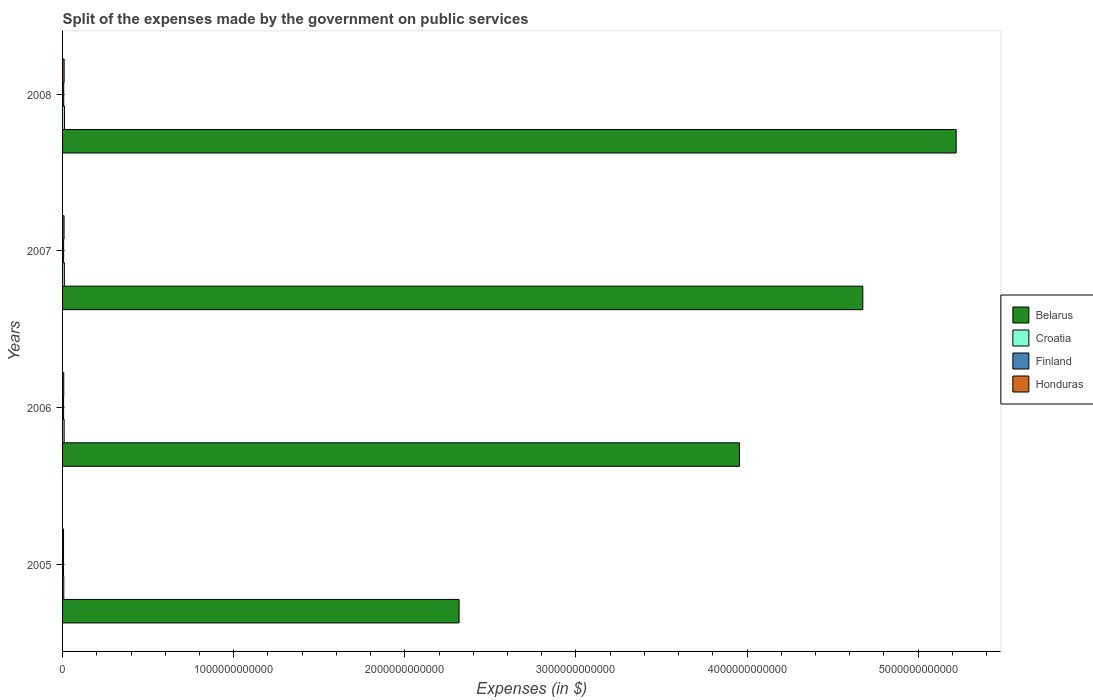How many groups of bars are there?
Keep it short and to the point. 4. How many bars are there on the 2nd tick from the top?
Your answer should be very brief. 4. What is the label of the 2nd group of bars from the top?
Your answer should be very brief. 2007. What is the expenses made by the government on public services in Honduras in 2005?
Ensure brevity in your answer.  5.77e+09. Across all years, what is the maximum expenses made by the government on public services in Croatia?
Give a very brief answer. 1.15e+1. Across all years, what is the minimum expenses made by the government on public services in Honduras?
Keep it short and to the point. 5.77e+09. In which year was the expenses made by the government on public services in Finland maximum?
Offer a very short reply. 2008. What is the total expenses made by the government on public services in Honduras in the graph?
Keep it short and to the point. 3.06e+1. What is the difference between the expenses made by the government on public services in Finland in 2005 and that in 2006?
Offer a terse response. -2.35e+08. What is the difference between the expenses made by the government on public services in Honduras in 2005 and the expenses made by the government on public services in Belarus in 2007?
Provide a succinct answer. -4.67e+12. What is the average expenses made by the government on public services in Croatia per year?
Make the answer very short. 9.57e+09. In the year 2007, what is the difference between the expenses made by the government on public services in Finland and expenses made by the government on public services in Belarus?
Provide a succinct answer. -4.67e+12. In how many years, is the expenses made by the government on public services in Croatia greater than 4600000000000 $?
Give a very brief answer. 0. What is the ratio of the expenses made by the government on public services in Belarus in 2005 to that in 2006?
Provide a succinct answer. 0.59. Is the expenses made by the government on public services in Honduras in 2005 less than that in 2006?
Offer a terse response. Yes. What is the difference between the highest and the second highest expenses made by the government on public services in Honduras?
Make the answer very short. 3.42e+08. What is the difference between the highest and the lowest expenses made by the government on public services in Honduras?
Your answer should be compact. 3.31e+09. In how many years, is the expenses made by the government on public services in Honduras greater than the average expenses made by the government on public services in Honduras taken over all years?
Your answer should be compact. 2. Is the sum of the expenses made by the government on public services in Belarus in 2006 and 2008 greater than the maximum expenses made by the government on public services in Honduras across all years?
Your answer should be very brief. Yes. Is it the case that in every year, the sum of the expenses made by the government on public services in Belarus and expenses made by the government on public services in Croatia is greater than the sum of expenses made by the government on public services in Honduras and expenses made by the government on public services in Finland?
Ensure brevity in your answer.  No. What does the 1st bar from the top in 2007 represents?
Keep it short and to the point. Honduras. What does the 1st bar from the bottom in 2006 represents?
Make the answer very short. Belarus. How many bars are there?
Make the answer very short. 16. What is the difference between two consecutive major ticks on the X-axis?
Give a very brief answer. 1.00e+12. Where does the legend appear in the graph?
Provide a short and direct response. Center right. How are the legend labels stacked?
Offer a terse response. Vertical. What is the title of the graph?
Give a very brief answer. Split of the expenses made by the government on public services. What is the label or title of the X-axis?
Ensure brevity in your answer.  Expenses (in $). What is the label or title of the Y-axis?
Provide a short and direct response. Years. What is the Expenses (in $) of Belarus in 2005?
Provide a short and direct response. 2.32e+12. What is the Expenses (in $) of Croatia in 2005?
Your response must be concise. 7.10e+09. What is the Expenses (in $) of Finland in 2005?
Give a very brief answer. 5.77e+09. What is the Expenses (in $) of Honduras in 2005?
Provide a succinct answer. 5.77e+09. What is the Expenses (in $) in Belarus in 2006?
Your response must be concise. 3.96e+12. What is the Expenses (in $) of Croatia in 2006?
Make the answer very short. 9.19e+09. What is the Expenses (in $) in Finland in 2006?
Make the answer very short. 6.00e+09. What is the Expenses (in $) in Honduras in 2006?
Your response must be concise. 7.04e+09. What is the Expenses (in $) of Belarus in 2007?
Provide a short and direct response. 4.68e+12. What is the Expenses (in $) in Croatia in 2007?
Make the answer very short. 1.05e+1. What is the Expenses (in $) of Finland in 2007?
Your response must be concise. 6.23e+09. What is the Expenses (in $) of Honduras in 2007?
Give a very brief answer. 8.74e+09. What is the Expenses (in $) of Belarus in 2008?
Offer a very short reply. 5.22e+12. What is the Expenses (in $) of Croatia in 2008?
Offer a terse response. 1.15e+1. What is the Expenses (in $) in Finland in 2008?
Keep it short and to the point. 6.73e+09. What is the Expenses (in $) in Honduras in 2008?
Provide a succinct answer. 9.08e+09. Across all years, what is the maximum Expenses (in $) in Belarus?
Keep it short and to the point. 5.22e+12. Across all years, what is the maximum Expenses (in $) in Croatia?
Provide a succinct answer. 1.15e+1. Across all years, what is the maximum Expenses (in $) in Finland?
Give a very brief answer. 6.73e+09. Across all years, what is the maximum Expenses (in $) in Honduras?
Provide a succinct answer. 9.08e+09. Across all years, what is the minimum Expenses (in $) in Belarus?
Provide a succinct answer. 2.32e+12. Across all years, what is the minimum Expenses (in $) in Croatia?
Give a very brief answer. 7.10e+09. Across all years, what is the minimum Expenses (in $) of Finland?
Offer a terse response. 5.77e+09. Across all years, what is the minimum Expenses (in $) in Honduras?
Offer a very short reply. 5.77e+09. What is the total Expenses (in $) of Belarus in the graph?
Provide a short and direct response. 1.62e+13. What is the total Expenses (in $) in Croatia in the graph?
Your answer should be very brief. 3.83e+1. What is the total Expenses (in $) of Finland in the graph?
Keep it short and to the point. 2.47e+1. What is the total Expenses (in $) of Honduras in the graph?
Make the answer very short. 3.06e+1. What is the difference between the Expenses (in $) in Belarus in 2005 and that in 2006?
Your answer should be compact. -1.64e+12. What is the difference between the Expenses (in $) of Croatia in 2005 and that in 2006?
Make the answer very short. -2.09e+09. What is the difference between the Expenses (in $) in Finland in 2005 and that in 2006?
Offer a terse response. -2.35e+08. What is the difference between the Expenses (in $) in Honduras in 2005 and that in 2006?
Your answer should be compact. -1.27e+09. What is the difference between the Expenses (in $) of Belarus in 2005 and that in 2007?
Provide a short and direct response. -2.36e+12. What is the difference between the Expenses (in $) of Croatia in 2005 and that in 2007?
Give a very brief answer. -3.42e+09. What is the difference between the Expenses (in $) of Finland in 2005 and that in 2007?
Ensure brevity in your answer.  -4.57e+08. What is the difference between the Expenses (in $) in Honduras in 2005 and that in 2007?
Offer a very short reply. -2.97e+09. What is the difference between the Expenses (in $) of Belarus in 2005 and that in 2008?
Give a very brief answer. -2.90e+12. What is the difference between the Expenses (in $) of Croatia in 2005 and that in 2008?
Your response must be concise. -4.37e+09. What is the difference between the Expenses (in $) of Finland in 2005 and that in 2008?
Make the answer very short. -9.64e+08. What is the difference between the Expenses (in $) of Honduras in 2005 and that in 2008?
Keep it short and to the point. -3.31e+09. What is the difference between the Expenses (in $) of Belarus in 2006 and that in 2007?
Your response must be concise. -7.21e+11. What is the difference between the Expenses (in $) in Croatia in 2006 and that in 2007?
Your answer should be very brief. -1.32e+09. What is the difference between the Expenses (in $) in Finland in 2006 and that in 2007?
Provide a short and direct response. -2.22e+08. What is the difference between the Expenses (in $) of Honduras in 2006 and that in 2007?
Offer a terse response. -1.70e+09. What is the difference between the Expenses (in $) of Belarus in 2006 and that in 2008?
Ensure brevity in your answer.  -1.27e+12. What is the difference between the Expenses (in $) of Croatia in 2006 and that in 2008?
Make the answer very short. -2.27e+09. What is the difference between the Expenses (in $) in Finland in 2006 and that in 2008?
Provide a succinct answer. -7.29e+08. What is the difference between the Expenses (in $) in Honduras in 2006 and that in 2008?
Give a very brief answer. -2.04e+09. What is the difference between the Expenses (in $) of Belarus in 2007 and that in 2008?
Keep it short and to the point. -5.46e+11. What is the difference between the Expenses (in $) in Croatia in 2007 and that in 2008?
Offer a terse response. -9.51e+08. What is the difference between the Expenses (in $) of Finland in 2007 and that in 2008?
Keep it short and to the point. -5.07e+08. What is the difference between the Expenses (in $) of Honduras in 2007 and that in 2008?
Make the answer very short. -3.42e+08. What is the difference between the Expenses (in $) of Belarus in 2005 and the Expenses (in $) of Croatia in 2006?
Give a very brief answer. 2.31e+12. What is the difference between the Expenses (in $) of Belarus in 2005 and the Expenses (in $) of Finland in 2006?
Offer a terse response. 2.31e+12. What is the difference between the Expenses (in $) of Belarus in 2005 and the Expenses (in $) of Honduras in 2006?
Provide a short and direct response. 2.31e+12. What is the difference between the Expenses (in $) of Croatia in 2005 and the Expenses (in $) of Finland in 2006?
Ensure brevity in your answer.  1.10e+09. What is the difference between the Expenses (in $) in Croatia in 2005 and the Expenses (in $) in Honduras in 2006?
Your response must be concise. 5.64e+07. What is the difference between the Expenses (in $) in Finland in 2005 and the Expenses (in $) in Honduras in 2006?
Your answer should be compact. -1.27e+09. What is the difference between the Expenses (in $) of Belarus in 2005 and the Expenses (in $) of Croatia in 2007?
Provide a short and direct response. 2.31e+12. What is the difference between the Expenses (in $) in Belarus in 2005 and the Expenses (in $) in Finland in 2007?
Offer a terse response. 2.31e+12. What is the difference between the Expenses (in $) in Belarus in 2005 and the Expenses (in $) in Honduras in 2007?
Give a very brief answer. 2.31e+12. What is the difference between the Expenses (in $) of Croatia in 2005 and the Expenses (in $) of Finland in 2007?
Give a very brief answer. 8.73e+08. What is the difference between the Expenses (in $) in Croatia in 2005 and the Expenses (in $) in Honduras in 2007?
Provide a succinct answer. -1.64e+09. What is the difference between the Expenses (in $) in Finland in 2005 and the Expenses (in $) in Honduras in 2007?
Your response must be concise. -2.97e+09. What is the difference between the Expenses (in $) in Belarus in 2005 and the Expenses (in $) in Croatia in 2008?
Your response must be concise. 2.31e+12. What is the difference between the Expenses (in $) in Belarus in 2005 and the Expenses (in $) in Finland in 2008?
Keep it short and to the point. 2.31e+12. What is the difference between the Expenses (in $) in Belarus in 2005 and the Expenses (in $) in Honduras in 2008?
Ensure brevity in your answer.  2.31e+12. What is the difference between the Expenses (in $) in Croatia in 2005 and the Expenses (in $) in Finland in 2008?
Keep it short and to the point. 3.66e+08. What is the difference between the Expenses (in $) in Croatia in 2005 and the Expenses (in $) in Honduras in 2008?
Offer a very short reply. -1.98e+09. What is the difference between the Expenses (in $) in Finland in 2005 and the Expenses (in $) in Honduras in 2008?
Provide a short and direct response. -3.31e+09. What is the difference between the Expenses (in $) in Belarus in 2006 and the Expenses (in $) in Croatia in 2007?
Your answer should be compact. 3.95e+12. What is the difference between the Expenses (in $) of Belarus in 2006 and the Expenses (in $) of Finland in 2007?
Provide a succinct answer. 3.95e+12. What is the difference between the Expenses (in $) in Belarus in 2006 and the Expenses (in $) in Honduras in 2007?
Your response must be concise. 3.95e+12. What is the difference between the Expenses (in $) of Croatia in 2006 and the Expenses (in $) of Finland in 2007?
Provide a short and direct response. 2.97e+09. What is the difference between the Expenses (in $) in Croatia in 2006 and the Expenses (in $) in Honduras in 2007?
Provide a succinct answer. 4.55e+08. What is the difference between the Expenses (in $) in Finland in 2006 and the Expenses (in $) in Honduras in 2007?
Provide a short and direct response. -2.73e+09. What is the difference between the Expenses (in $) of Belarus in 2006 and the Expenses (in $) of Croatia in 2008?
Offer a very short reply. 3.94e+12. What is the difference between the Expenses (in $) in Belarus in 2006 and the Expenses (in $) in Finland in 2008?
Offer a terse response. 3.95e+12. What is the difference between the Expenses (in $) in Belarus in 2006 and the Expenses (in $) in Honduras in 2008?
Provide a succinct answer. 3.95e+12. What is the difference between the Expenses (in $) in Croatia in 2006 and the Expenses (in $) in Finland in 2008?
Your answer should be very brief. 2.46e+09. What is the difference between the Expenses (in $) in Croatia in 2006 and the Expenses (in $) in Honduras in 2008?
Your answer should be very brief. 1.13e+08. What is the difference between the Expenses (in $) of Finland in 2006 and the Expenses (in $) of Honduras in 2008?
Give a very brief answer. -3.08e+09. What is the difference between the Expenses (in $) in Belarus in 2007 and the Expenses (in $) in Croatia in 2008?
Offer a terse response. 4.67e+12. What is the difference between the Expenses (in $) of Belarus in 2007 and the Expenses (in $) of Finland in 2008?
Your answer should be very brief. 4.67e+12. What is the difference between the Expenses (in $) of Belarus in 2007 and the Expenses (in $) of Honduras in 2008?
Provide a short and direct response. 4.67e+12. What is the difference between the Expenses (in $) of Croatia in 2007 and the Expenses (in $) of Finland in 2008?
Your answer should be compact. 3.78e+09. What is the difference between the Expenses (in $) of Croatia in 2007 and the Expenses (in $) of Honduras in 2008?
Keep it short and to the point. 1.44e+09. What is the difference between the Expenses (in $) in Finland in 2007 and the Expenses (in $) in Honduras in 2008?
Offer a terse response. -2.85e+09. What is the average Expenses (in $) in Belarus per year?
Your answer should be very brief. 4.04e+12. What is the average Expenses (in $) of Croatia per year?
Your response must be concise. 9.57e+09. What is the average Expenses (in $) in Finland per year?
Ensure brevity in your answer.  6.18e+09. What is the average Expenses (in $) in Honduras per year?
Your response must be concise. 7.66e+09. In the year 2005, what is the difference between the Expenses (in $) of Belarus and Expenses (in $) of Croatia?
Your answer should be very brief. 2.31e+12. In the year 2005, what is the difference between the Expenses (in $) of Belarus and Expenses (in $) of Finland?
Your answer should be very brief. 2.31e+12. In the year 2005, what is the difference between the Expenses (in $) of Belarus and Expenses (in $) of Honduras?
Give a very brief answer. 2.31e+12. In the year 2005, what is the difference between the Expenses (in $) in Croatia and Expenses (in $) in Finland?
Your response must be concise. 1.33e+09. In the year 2005, what is the difference between the Expenses (in $) of Croatia and Expenses (in $) of Honduras?
Your answer should be compact. 1.33e+09. In the year 2005, what is the difference between the Expenses (in $) of Finland and Expenses (in $) of Honduras?
Offer a very short reply. -2.10e+06. In the year 2006, what is the difference between the Expenses (in $) in Belarus and Expenses (in $) in Croatia?
Your response must be concise. 3.95e+12. In the year 2006, what is the difference between the Expenses (in $) in Belarus and Expenses (in $) in Finland?
Provide a short and direct response. 3.95e+12. In the year 2006, what is the difference between the Expenses (in $) in Belarus and Expenses (in $) in Honduras?
Ensure brevity in your answer.  3.95e+12. In the year 2006, what is the difference between the Expenses (in $) of Croatia and Expenses (in $) of Finland?
Your response must be concise. 3.19e+09. In the year 2006, what is the difference between the Expenses (in $) in Croatia and Expenses (in $) in Honduras?
Offer a very short reply. 2.15e+09. In the year 2006, what is the difference between the Expenses (in $) of Finland and Expenses (in $) of Honduras?
Your answer should be very brief. -1.04e+09. In the year 2007, what is the difference between the Expenses (in $) of Belarus and Expenses (in $) of Croatia?
Offer a terse response. 4.67e+12. In the year 2007, what is the difference between the Expenses (in $) in Belarus and Expenses (in $) in Finland?
Offer a terse response. 4.67e+12. In the year 2007, what is the difference between the Expenses (in $) of Belarus and Expenses (in $) of Honduras?
Provide a short and direct response. 4.67e+12. In the year 2007, what is the difference between the Expenses (in $) in Croatia and Expenses (in $) in Finland?
Ensure brevity in your answer.  4.29e+09. In the year 2007, what is the difference between the Expenses (in $) in Croatia and Expenses (in $) in Honduras?
Give a very brief answer. 1.78e+09. In the year 2007, what is the difference between the Expenses (in $) of Finland and Expenses (in $) of Honduras?
Your answer should be very brief. -2.51e+09. In the year 2008, what is the difference between the Expenses (in $) in Belarus and Expenses (in $) in Croatia?
Make the answer very short. 5.21e+12. In the year 2008, what is the difference between the Expenses (in $) of Belarus and Expenses (in $) of Finland?
Offer a terse response. 5.22e+12. In the year 2008, what is the difference between the Expenses (in $) in Belarus and Expenses (in $) in Honduras?
Ensure brevity in your answer.  5.21e+12. In the year 2008, what is the difference between the Expenses (in $) of Croatia and Expenses (in $) of Finland?
Your response must be concise. 4.73e+09. In the year 2008, what is the difference between the Expenses (in $) of Croatia and Expenses (in $) of Honduras?
Provide a short and direct response. 2.39e+09. In the year 2008, what is the difference between the Expenses (in $) in Finland and Expenses (in $) in Honduras?
Your answer should be very brief. -2.35e+09. What is the ratio of the Expenses (in $) of Belarus in 2005 to that in 2006?
Provide a succinct answer. 0.59. What is the ratio of the Expenses (in $) in Croatia in 2005 to that in 2006?
Provide a succinct answer. 0.77. What is the ratio of the Expenses (in $) in Finland in 2005 to that in 2006?
Keep it short and to the point. 0.96. What is the ratio of the Expenses (in $) in Honduras in 2005 to that in 2006?
Give a very brief answer. 0.82. What is the ratio of the Expenses (in $) of Belarus in 2005 to that in 2007?
Make the answer very short. 0.5. What is the ratio of the Expenses (in $) of Croatia in 2005 to that in 2007?
Keep it short and to the point. 0.68. What is the ratio of the Expenses (in $) of Finland in 2005 to that in 2007?
Provide a succinct answer. 0.93. What is the ratio of the Expenses (in $) in Honduras in 2005 to that in 2007?
Keep it short and to the point. 0.66. What is the ratio of the Expenses (in $) of Belarus in 2005 to that in 2008?
Your answer should be very brief. 0.44. What is the ratio of the Expenses (in $) in Croatia in 2005 to that in 2008?
Your response must be concise. 0.62. What is the ratio of the Expenses (in $) in Finland in 2005 to that in 2008?
Offer a terse response. 0.86. What is the ratio of the Expenses (in $) in Honduras in 2005 to that in 2008?
Your answer should be very brief. 0.64. What is the ratio of the Expenses (in $) in Belarus in 2006 to that in 2007?
Provide a short and direct response. 0.85. What is the ratio of the Expenses (in $) in Croatia in 2006 to that in 2007?
Provide a short and direct response. 0.87. What is the ratio of the Expenses (in $) in Honduras in 2006 to that in 2007?
Your response must be concise. 0.81. What is the ratio of the Expenses (in $) of Belarus in 2006 to that in 2008?
Offer a very short reply. 0.76. What is the ratio of the Expenses (in $) in Croatia in 2006 to that in 2008?
Your answer should be compact. 0.8. What is the ratio of the Expenses (in $) in Finland in 2006 to that in 2008?
Offer a terse response. 0.89. What is the ratio of the Expenses (in $) of Honduras in 2006 to that in 2008?
Offer a terse response. 0.78. What is the ratio of the Expenses (in $) in Belarus in 2007 to that in 2008?
Provide a short and direct response. 0.9. What is the ratio of the Expenses (in $) in Croatia in 2007 to that in 2008?
Your answer should be compact. 0.92. What is the ratio of the Expenses (in $) in Finland in 2007 to that in 2008?
Provide a short and direct response. 0.92. What is the ratio of the Expenses (in $) of Honduras in 2007 to that in 2008?
Offer a very short reply. 0.96. What is the difference between the highest and the second highest Expenses (in $) in Belarus?
Your answer should be very brief. 5.46e+11. What is the difference between the highest and the second highest Expenses (in $) in Croatia?
Provide a short and direct response. 9.51e+08. What is the difference between the highest and the second highest Expenses (in $) in Finland?
Keep it short and to the point. 5.07e+08. What is the difference between the highest and the second highest Expenses (in $) in Honduras?
Provide a succinct answer. 3.42e+08. What is the difference between the highest and the lowest Expenses (in $) of Belarus?
Offer a very short reply. 2.90e+12. What is the difference between the highest and the lowest Expenses (in $) of Croatia?
Offer a terse response. 4.37e+09. What is the difference between the highest and the lowest Expenses (in $) of Finland?
Ensure brevity in your answer.  9.64e+08. What is the difference between the highest and the lowest Expenses (in $) in Honduras?
Provide a succinct answer. 3.31e+09. 